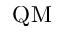<formula> <loc_0><loc_0><loc_500><loc_500>Q M</formula> 